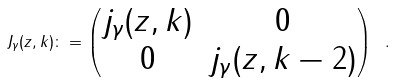Convert formula to latex. <formula><loc_0><loc_0><loc_500><loc_500>J _ { \gamma } ( z , k ) \colon = \begin{pmatrix} j _ { \gamma } ( z , k ) & 0 \\ 0 & j _ { \gamma } ( z , k - 2 ) \end{pmatrix} \ .</formula> 